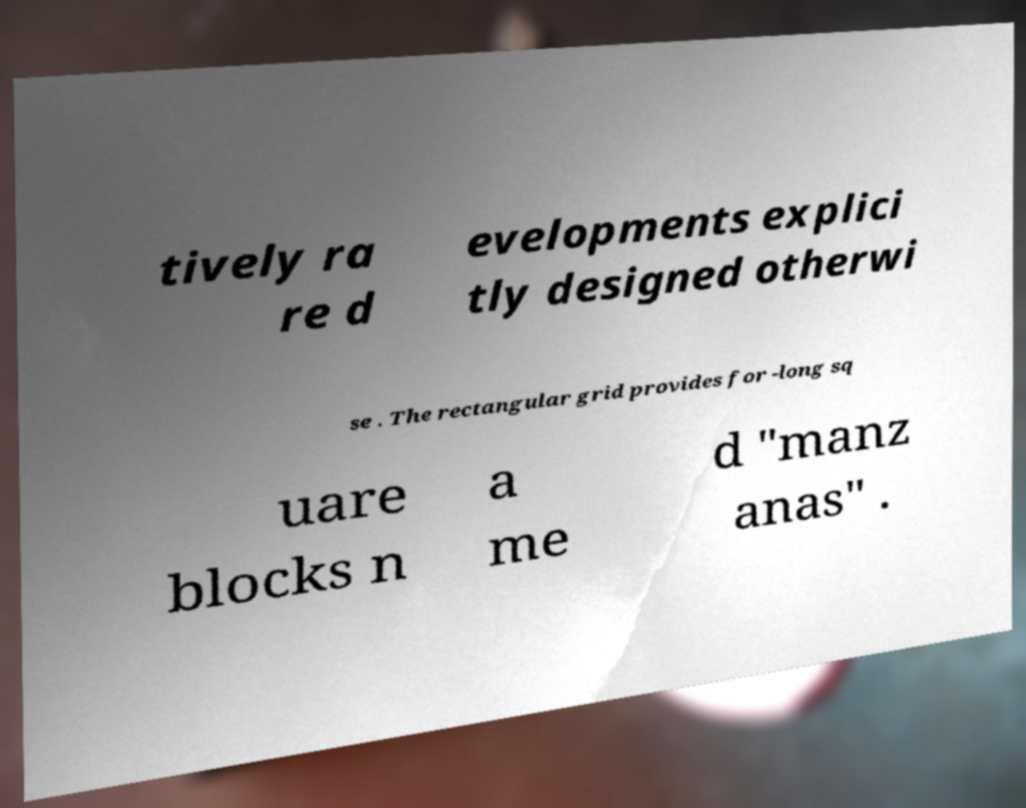Can you accurately transcribe the text from the provided image for me? tively ra re d evelopments explici tly designed otherwi se . The rectangular grid provides for -long sq uare blocks n a me d "manz anas" . 